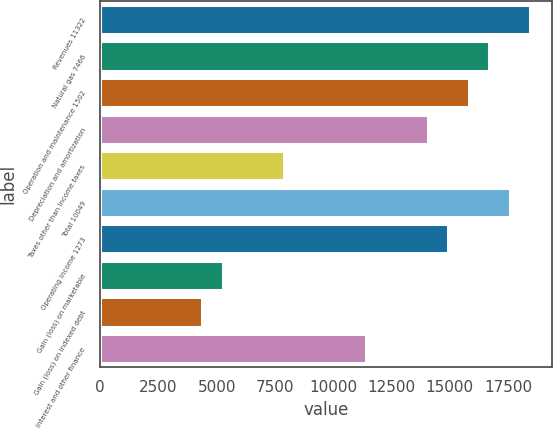<chart> <loc_0><loc_0><loc_500><loc_500><bar_chart><fcel>Revenues 11322<fcel>Natural gas 7466<fcel>Operation and maintenance 1502<fcel>Depreciation and amortization<fcel>Taxes other than income taxes<fcel>Total 10049<fcel>Operating Income 1273<fcel>Gain (loss) on marketable<fcel>Gain (loss) on indexed debt<fcel>Interest and other finance<nl><fcel>18447.6<fcel>16690.8<fcel>15812.3<fcel>14055.5<fcel>7906.56<fcel>17569.2<fcel>14933.9<fcel>5271.3<fcel>4392.88<fcel>11420.2<nl></chart> 